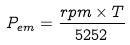Convert formula to latex. <formula><loc_0><loc_0><loc_500><loc_500>P _ { e m } = \frac { r p m \times T } { 5 2 5 2 }</formula> 